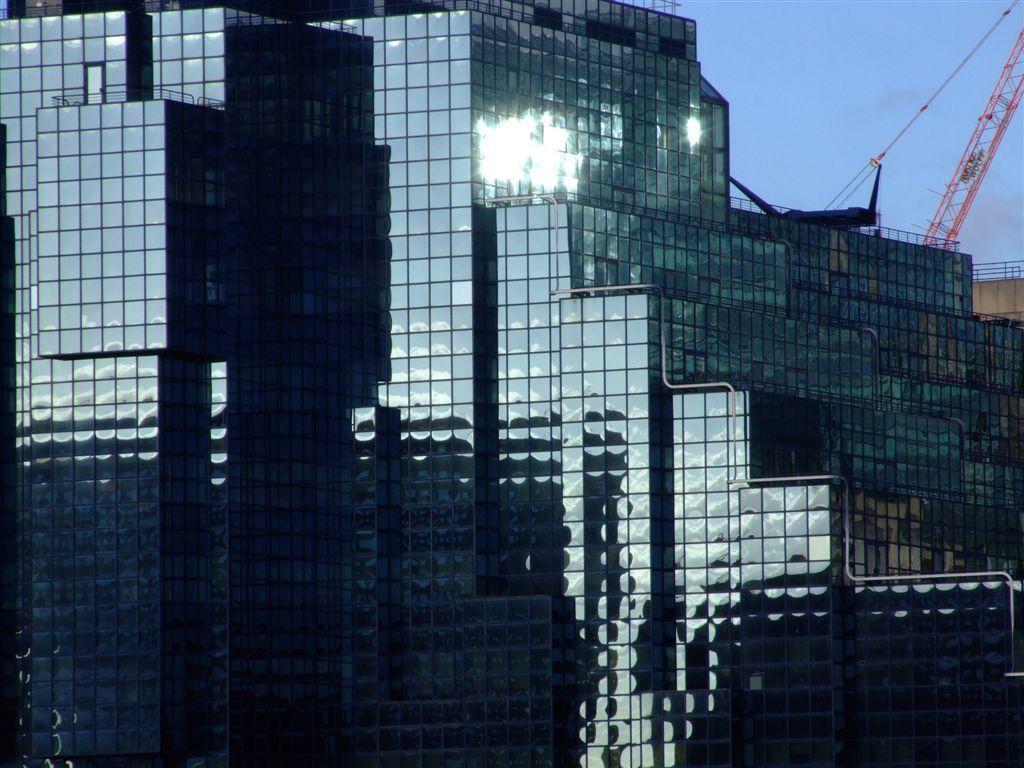Can you describe this image briefly? In this image we can see the outside view of the glass building. Sky is also visible in this image. 